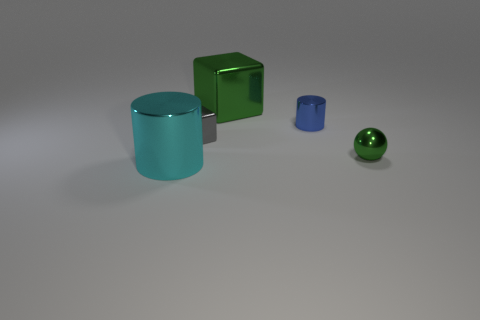Subtract all cubes. How many objects are left? 3 Add 4 tiny blue matte things. How many objects exist? 9 Subtract all blue cylinders. How many cylinders are left? 1 Subtract 1 cubes. How many cubes are left? 1 Subtract 0 yellow cylinders. How many objects are left? 5 Subtract all gray cylinders. Subtract all red balls. How many cylinders are left? 2 Subtract all cyan cubes. How many blue cylinders are left? 1 Subtract all large red blocks. Subtract all metallic things. How many objects are left? 0 Add 1 small shiny objects. How many small shiny objects are left? 4 Add 5 gray rubber objects. How many gray rubber objects exist? 5 